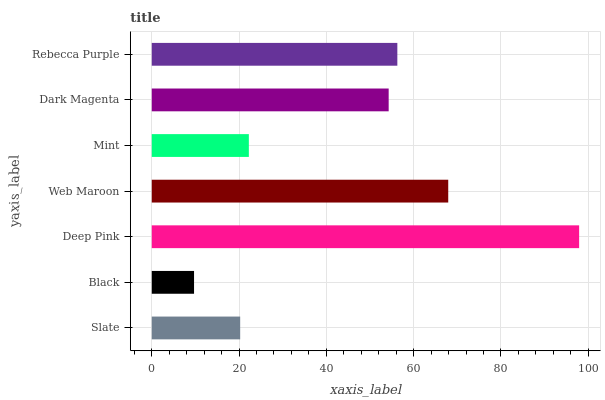Is Black the minimum?
Answer yes or no. Yes. Is Deep Pink the maximum?
Answer yes or no. Yes. Is Deep Pink the minimum?
Answer yes or no. No. Is Black the maximum?
Answer yes or no. No. Is Deep Pink greater than Black?
Answer yes or no. Yes. Is Black less than Deep Pink?
Answer yes or no. Yes. Is Black greater than Deep Pink?
Answer yes or no. No. Is Deep Pink less than Black?
Answer yes or no. No. Is Dark Magenta the high median?
Answer yes or no. Yes. Is Dark Magenta the low median?
Answer yes or no. Yes. Is Black the high median?
Answer yes or no. No. Is Slate the low median?
Answer yes or no. No. 